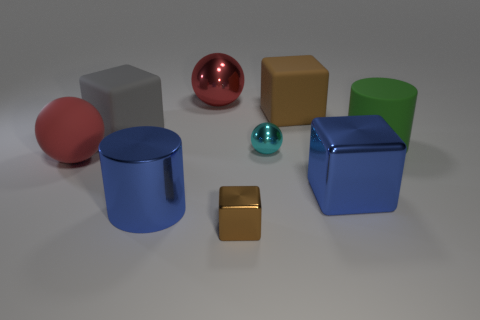Subtract all gray blocks. How many blocks are left? 3 Subtract all big gray rubber cubes. How many cubes are left? 3 Subtract 3 blocks. How many blocks are left? 1 Add 1 large blue shiny cubes. How many objects exist? 10 Subtract all balls. How many objects are left? 6 Subtract all blue cubes. Subtract all cyan cylinders. How many cubes are left? 3 Subtract all matte cylinders. Subtract all small blue rubber cubes. How many objects are left? 8 Add 6 big red shiny things. How many big red shiny things are left? 7 Add 4 brown matte blocks. How many brown matte blocks exist? 5 Subtract 0 yellow balls. How many objects are left? 9 